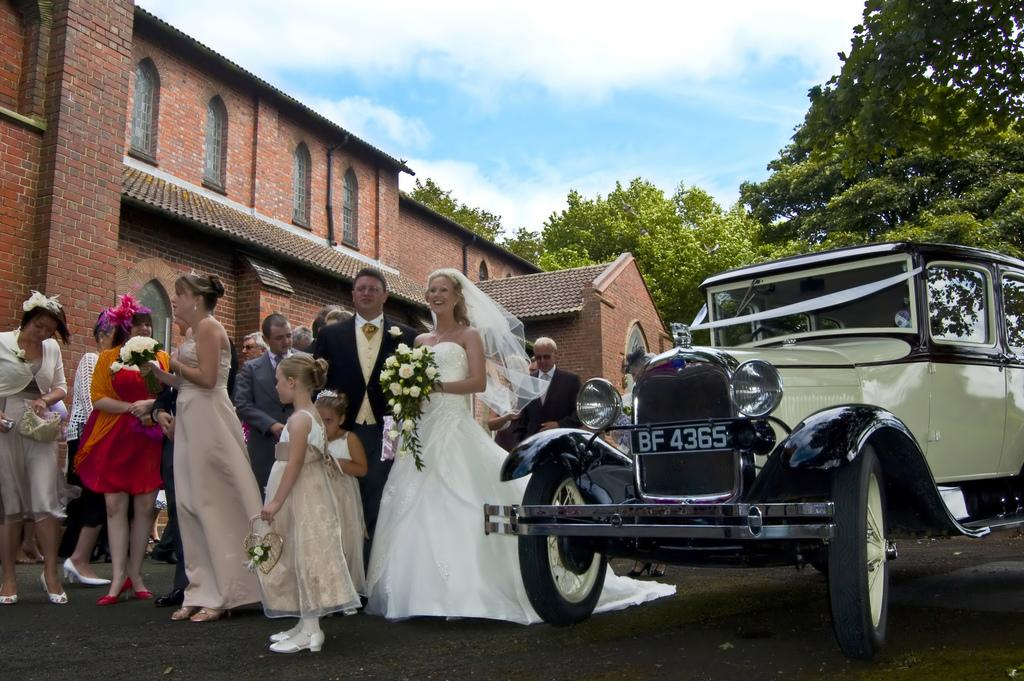How many people are in the group visible in the image? There is a group of people in the image, but the exact number cannot be determined from the provided facts. What are some people in the group holding? Some people in the group are holding bouquets. What is located beside the group of people? There is a car beside the group of people. What can be seen in the background of the image? There are trees, clouds, and a building in the background of the image. What type of question is being asked in the image? There is no indication in the image that a question is being asked. What is the scene of the image expanding into? The image is a static representation and does not expand into any scene. 